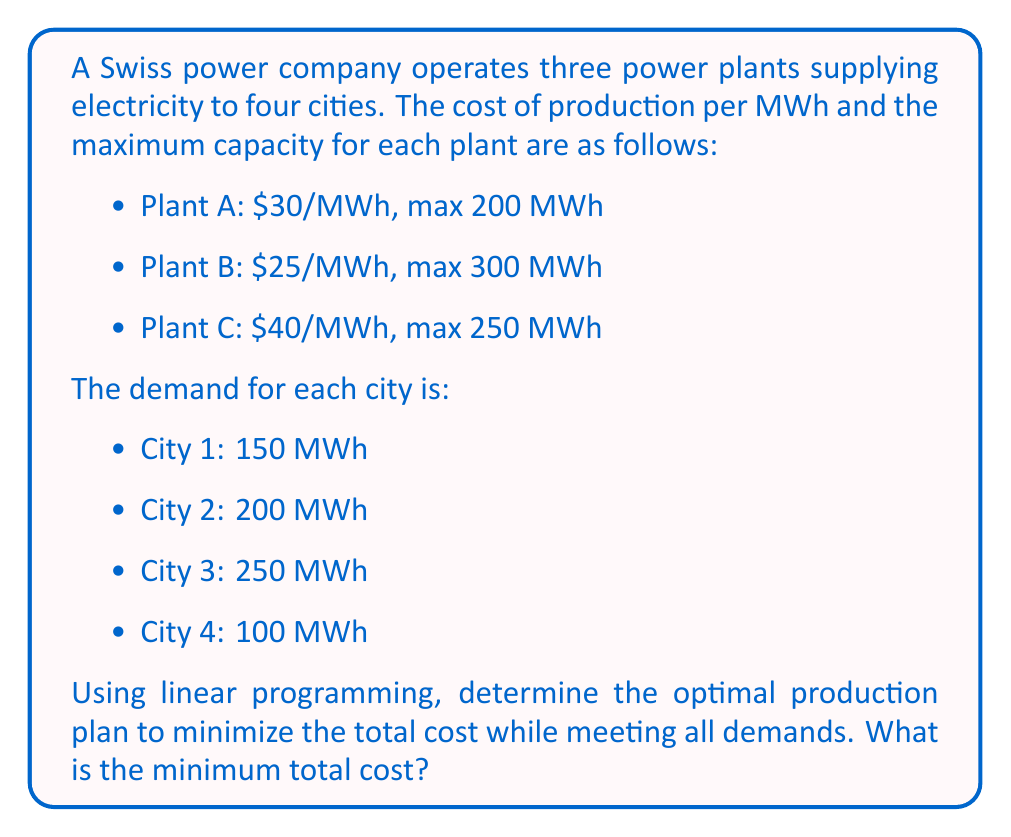Give your solution to this math problem. To solve this problem using linear programming, we need to formulate the objective function and constraints.

Let $x_A$, $x_B$, and $x_C$ represent the production in MWh from plants A, B, and C, respectively.

Objective function (minimize total cost):
$$\text{minimize } Z = 30x_A + 25x_B + 40x_C$$

Constraints:
1. Production limits:
   $$0 \leq x_A \leq 200$$
   $$0 \leq x_B \leq 300$$
   $$0 \leq x_C \leq 250$$

2. Demand satisfaction:
   $$x_A + x_B + x_C = 150 + 200 + 250 + 100 = 700$$

To solve this linear programming problem, we can use the simplex method or a solver. However, we can also reason through the solution:

1. The total demand is 700 MWh, which is less than the combined capacity of the three plants (750 MWh).

2. To minimize cost, we should prioritize production from the cheapest plant (Plant B) to the most expensive (Plant C).

3. Optimal production plan:
   - Plant B: Produce at max capacity: 300 MWh
   - Plant A: Produce the remaining demand: 700 - 300 = 400 MWh, but this exceeds its capacity. So, produce at max capacity: 200 MWh
   - Plant C: Produce the remaining demand: 700 - 300 - 200 = 200 MWh

4. Calculate the total cost:
   $$\text{Total Cost} = (30 \times 200) + (25 \times 300) + (40 \times 200)$$
Answer: The minimum total cost is $19,500. 